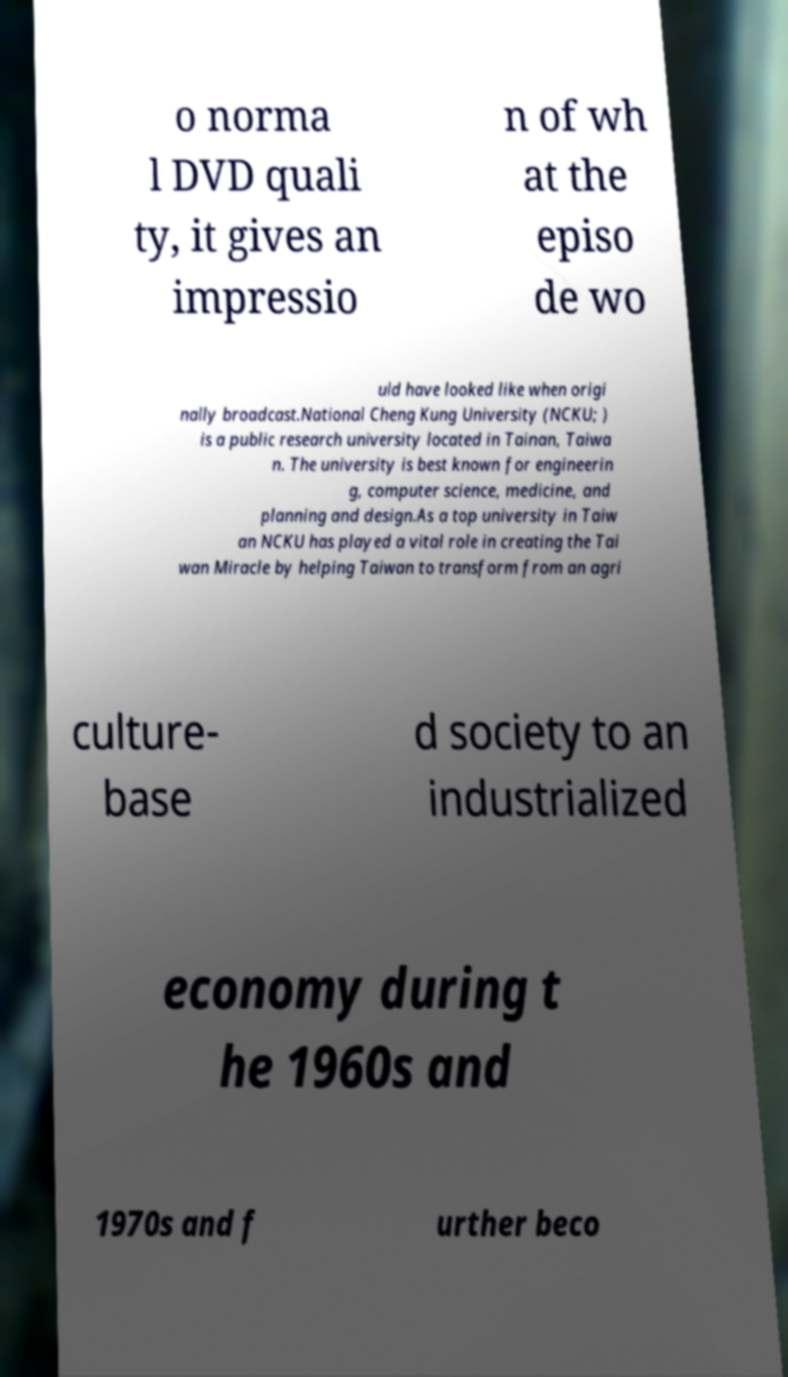Can you accurately transcribe the text from the provided image for me? o norma l DVD quali ty, it gives an impressio n of wh at the episo de wo uld have looked like when origi nally broadcast.National Cheng Kung University (NCKU; ) is a public research university located in Tainan, Taiwa n. The university is best known for engineerin g, computer science, medicine, and planning and design.As a top university in Taiw an NCKU has played a vital role in creating the Tai wan Miracle by helping Taiwan to transform from an agri culture- base d society to an industrialized economy during t he 1960s and 1970s and f urther beco 